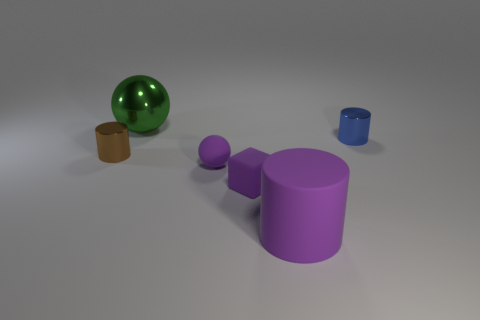Does the blue object have the same shape as the large thing that is behind the blue metallic cylinder?
Your answer should be compact. No. There is a ball that is the same color as the rubber cylinder; what is its material?
Your response must be concise. Rubber. What is the color of the rubber sphere that is the same size as the rubber block?
Offer a terse response. Purple. There is a matte thing that is the same shape as the blue shiny thing; what color is it?
Provide a succinct answer. Purple. How many things are large green balls or big objects that are behind the brown object?
Give a very brief answer. 1. Are there fewer blocks left of the large shiny sphere than blue rubber objects?
Your response must be concise. No. There is a blue cylinder on the right side of the thing in front of the small purple matte block to the left of the big purple matte thing; what size is it?
Keep it short and to the point. Small. The shiny object that is left of the tiny blue metal cylinder and in front of the metal ball is what color?
Make the answer very short. Brown. How many tiny purple matte cubes are there?
Your answer should be compact. 1. Is the material of the large cylinder the same as the large sphere?
Give a very brief answer. No. 